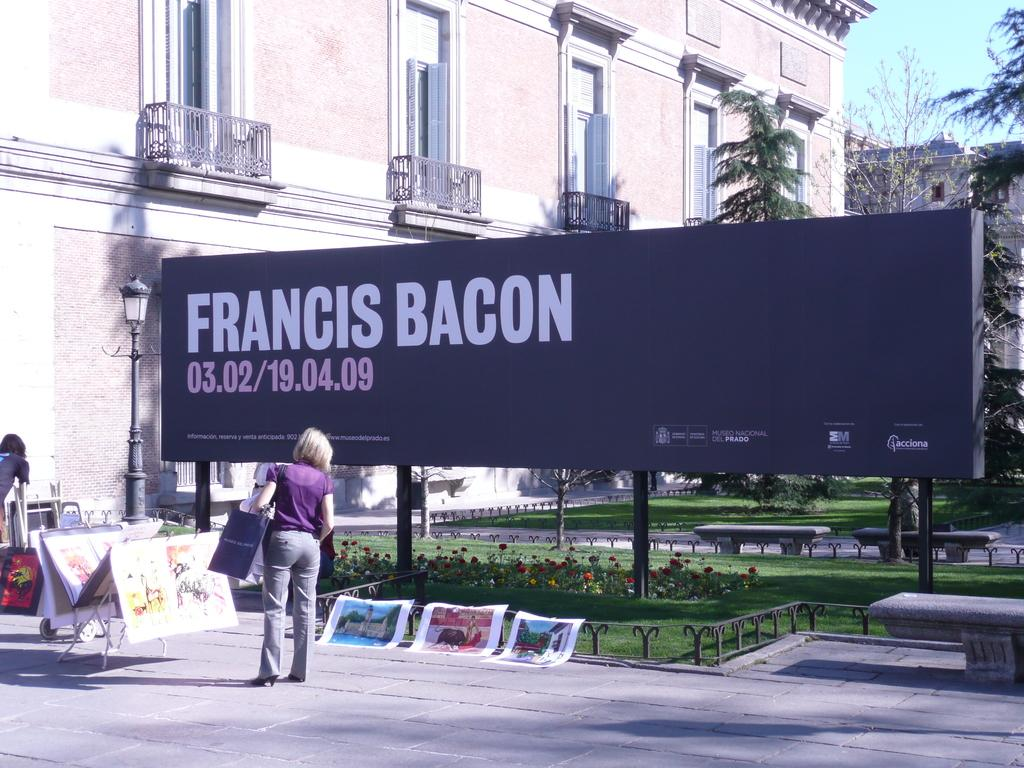<image>
Offer a succinct explanation of the picture presented. a sign that is all black and says 'francis bacon' 